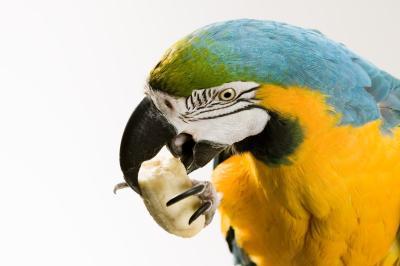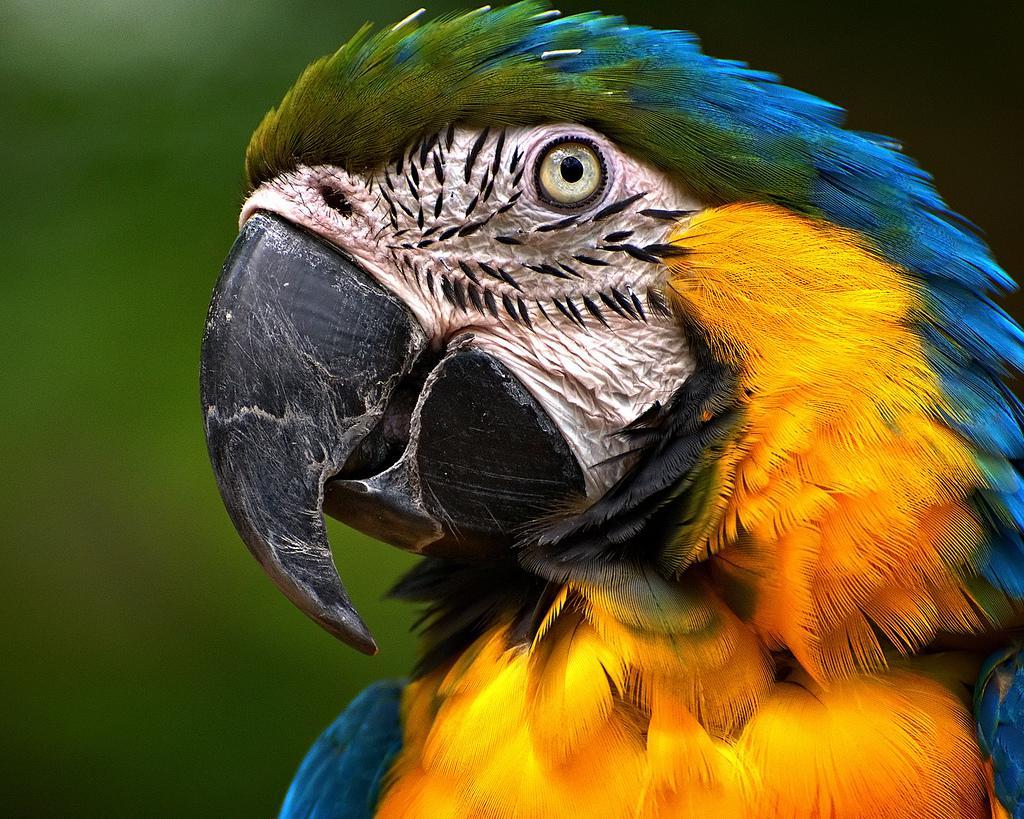The first image is the image on the left, the second image is the image on the right. Evaluate the accuracy of this statement regarding the images: "Each image shows a single parrot surrounded by leafy green foliage, and all parrots have heads angled leftward.". Is it true? Answer yes or no. No. The first image is the image on the left, the second image is the image on the right. Analyze the images presented: Is the assertion "One macaw is not eating anything." valid? Answer yes or no. Yes. 